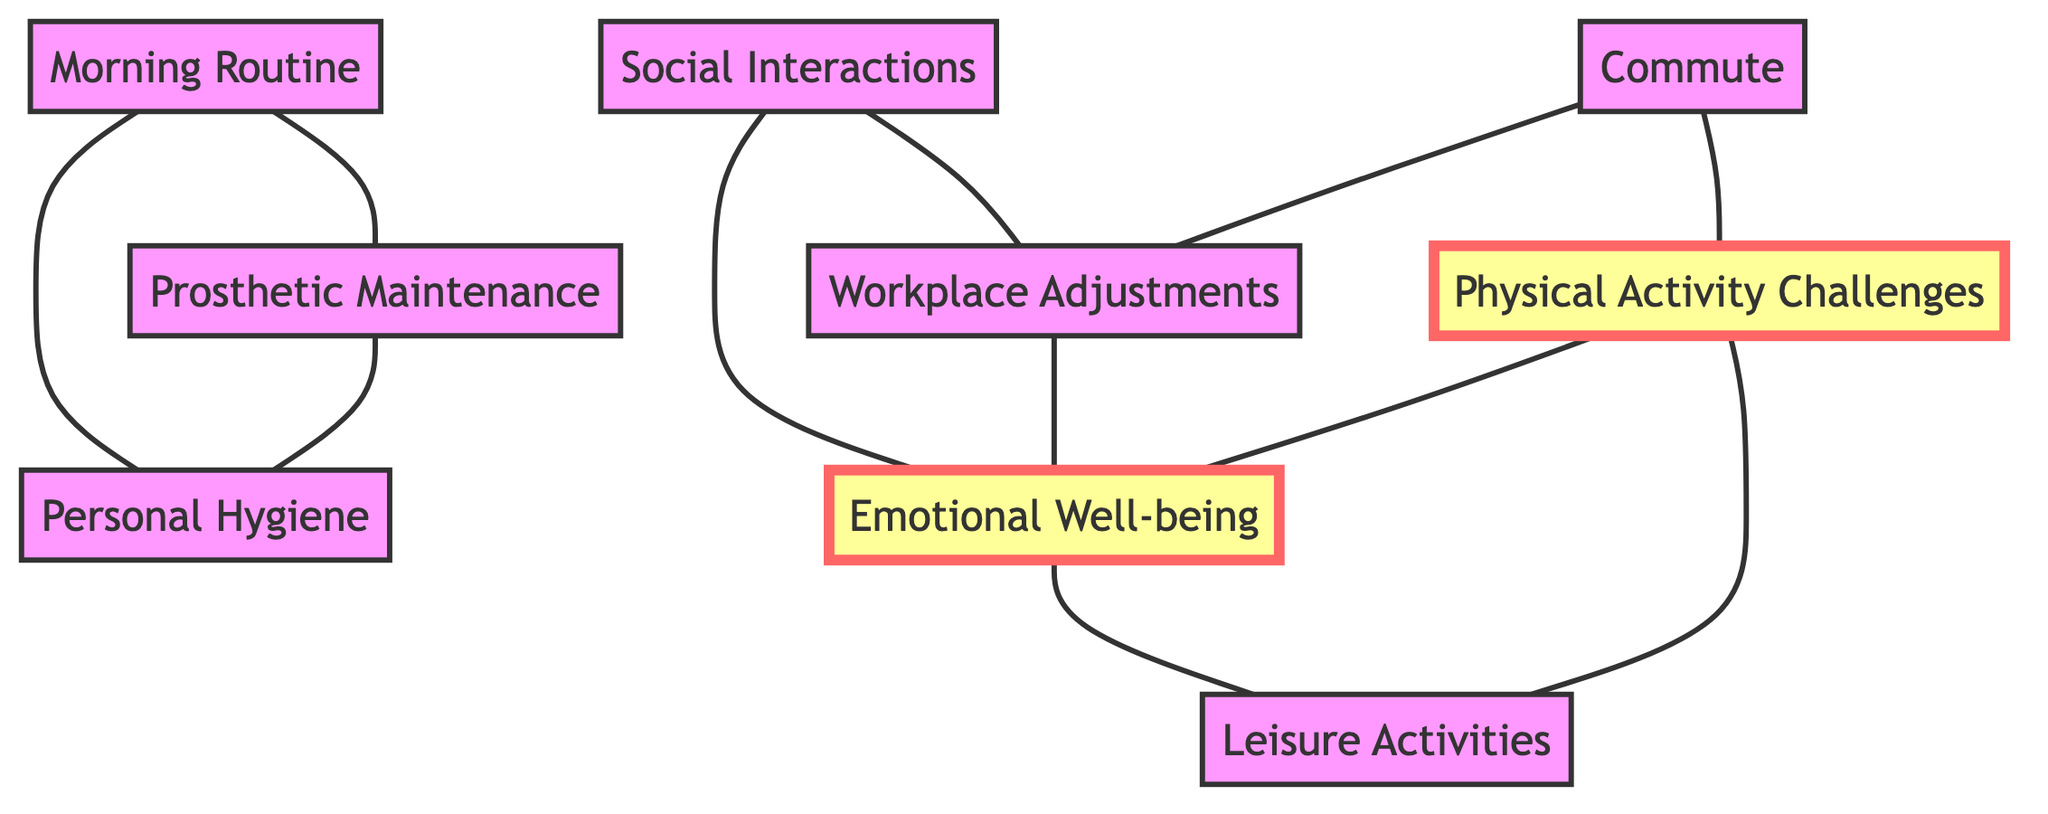what nodes are connected to Physical Activity Challenges? By examining the edges emanating from the node labeled "Physical Activity Challenges", we see connections to "Emotional Well-being" and "Leisure Activities".
Answer: Emotional Well-being, Leisure Activities how many total nodes are in the diagram? By counting each listed node in the data, we find there are a total of 9 nodes.
Answer: 9 what is the relationship between Workplace Adjustments and Emotional Well-being? Looking at the edges, "Workplace Adjustments" is connected to "Emotional Well-being" indicating that one influences the other.
Answer: influences which node has the most connections? By analyzing the edges, "Emotional Well-being" connects to three other nodes: "Physical Activity Challenges", "Social Interactions", and "Leisure Activities", making it the most connected node.
Answer: Emotional Well-being how do Morning Routine and Personal Hygiene relate? The edge labeled "component of" indicates that "Personal Hygiene" is a part of "Morning Routine".
Answer: component of which two nodes are directly connected to Commute? The connections show that "Commute" is directly linked to "Workplace Adjustments" and "Physical Activity Challenges".
Answer: Workplace Adjustments, Physical Activity Challenges what types of activities does Physical Activity Challenges influence? From the diagram, "Physical Activity Challenges" directly involves "Leisure Activities" and impacts "Emotional Well-being".
Answer: Leisure Activities, Emotional Well-being how does Prosthetic Maintenance relate to Personal Hygiene? Analyzing the edges, we see that "Prosthetic Maintenance" includes aspects of "Personal Hygiene", indicating a necessary relationship.
Answer: includes 